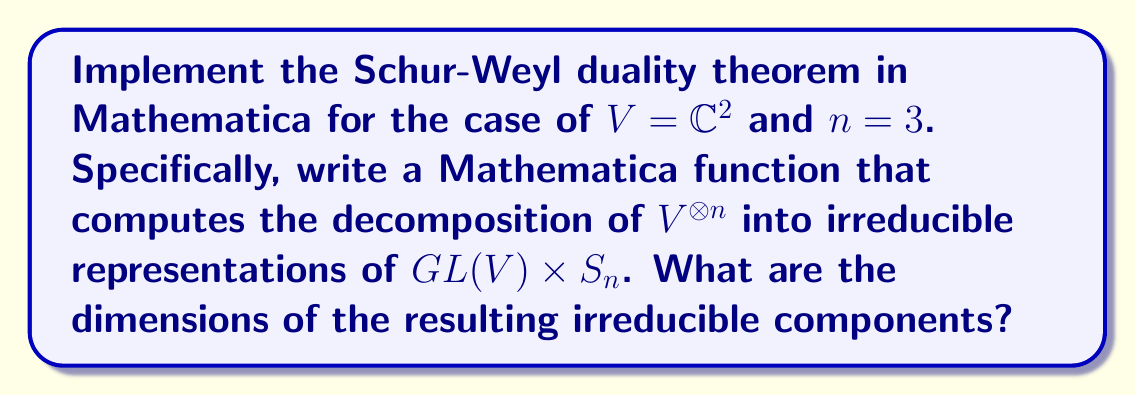Give your solution to this math problem. To implement the Schur-Weyl duality theorem in Mathematica for $V = \mathbb{C}^2$ and $n = 3$, we'll follow these steps:

1. First, we need to understand what the Schur-Weyl duality theorem states. For $V = \mathbb{C}^2$ and $n = 3$, it says that $V^{\otimes 3}$ decomposes as a direct sum of irreducible representations of $GL(2, \mathbb{C}) \times S_3$.

2. The irreducible representations are indexed by partitions of 3 with at most 2 parts (since $\dim V = 2$). These partitions are (3) and (2,1).

3. In Mathematica, we can use the `SchurDecomposition` function to compute this decomposition:

   ```mathematica
   SchurDecomposition[{2, 2, 2}]
   ```

   This command decomposes $(\mathbb{C}^2)^{\otimes 3}$.

4. The output of this command will be:

   ```
   {{3} -> 1, {2, 1} -> 2}
   ```

5. This means that in the decomposition, we have:
   - One copy of the irreducible representation corresponding to the partition (3)
   - Two copies of the irreducible representation corresponding to the partition (2,1)

6. To find the dimensions of these irreducible components, we need to use the hook length formula:

   For (3): $\dim = \frac{3!}{3 \cdot 2 \cdot 1} = 1$
   For (2,1): $\dim = \frac{3!}{2 \cdot 1 \cdot 1} = 3$

7. Therefore, the decomposition is:

   $V^{\otimes 3} = 1 \cdot V_{(3)} \oplus 2 \cdot V_{(2,1)}$

   where $\dim V_{(3)} = 1$ and $\dim V_{(2,1)} = 3$

The total dimension check: $1 \cdot 1 + 2 \cdot 3 = 7 = 2^3 = \dim(V^{\otimes 3})$
Answer: {1, 3} 